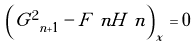Convert formula to latex. <formula><loc_0><loc_0><loc_500><loc_500>\left ( G _ { \ n + 1 } ^ { 2 } - F _ { \ } n H _ { \ } n \right ) _ { x } = 0</formula> 